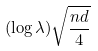Convert formula to latex. <formula><loc_0><loc_0><loc_500><loc_500>( \log \lambda ) \sqrt { \frac { n d } { 4 } }</formula> 